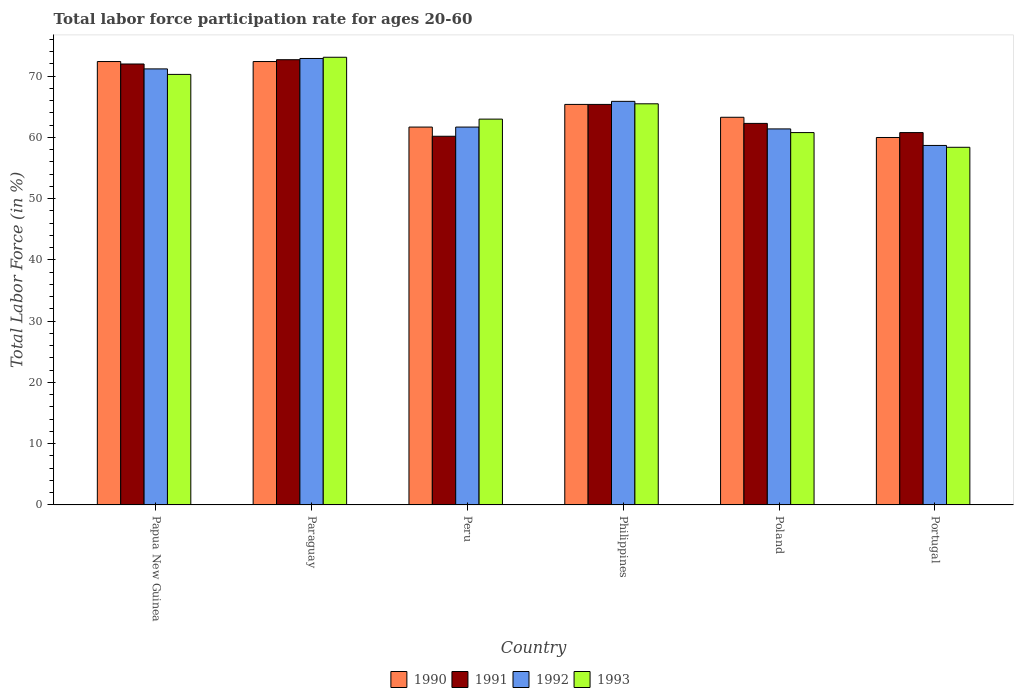How many groups of bars are there?
Offer a terse response. 6. Are the number of bars on each tick of the X-axis equal?
Provide a short and direct response. Yes. How many bars are there on the 3rd tick from the left?
Ensure brevity in your answer.  4. How many bars are there on the 4th tick from the right?
Keep it short and to the point. 4. What is the labor force participation rate in 1991 in Portugal?
Your response must be concise. 60.8. Across all countries, what is the maximum labor force participation rate in 1991?
Ensure brevity in your answer.  72.7. Across all countries, what is the minimum labor force participation rate in 1991?
Your response must be concise. 60.2. In which country was the labor force participation rate in 1991 maximum?
Your answer should be very brief. Paraguay. In which country was the labor force participation rate in 1992 minimum?
Keep it short and to the point. Portugal. What is the total labor force participation rate in 1990 in the graph?
Ensure brevity in your answer.  395.2. What is the difference between the labor force participation rate in 1991 in Paraguay and that in Peru?
Offer a terse response. 12.5. What is the difference between the labor force participation rate in 1991 in Poland and the labor force participation rate in 1993 in Paraguay?
Your response must be concise. -10.8. What is the average labor force participation rate in 1991 per country?
Your answer should be compact. 65.57. What is the difference between the labor force participation rate of/in 1992 and labor force participation rate of/in 1993 in Paraguay?
Your response must be concise. -0.2. In how many countries, is the labor force participation rate in 1990 greater than 26 %?
Ensure brevity in your answer.  6. What is the ratio of the labor force participation rate in 1990 in Papua New Guinea to that in Philippines?
Provide a short and direct response. 1.11. What is the difference between the highest and the second highest labor force participation rate in 1992?
Your response must be concise. 7. What is the difference between the highest and the lowest labor force participation rate in 1992?
Your answer should be compact. 14.2. Is the sum of the labor force participation rate in 1992 in Paraguay and Philippines greater than the maximum labor force participation rate in 1991 across all countries?
Give a very brief answer. Yes. What does the 4th bar from the right in Paraguay represents?
Your answer should be very brief. 1990. Is it the case that in every country, the sum of the labor force participation rate in 1991 and labor force participation rate in 1992 is greater than the labor force participation rate in 1993?
Make the answer very short. Yes. Are the values on the major ticks of Y-axis written in scientific E-notation?
Make the answer very short. No. Does the graph contain any zero values?
Offer a very short reply. No. Where does the legend appear in the graph?
Make the answer very short. Bottom center. How many legend labels are there?
Your answer should be very brief. 4. What is the title of the graph?
Your answer should be compact. Total labor force participation rate for ages 20-60. Does "1993" appear as one of the legend labels in the graph?
Provide a succinct answer. Yes. What is the label or title of the X-axis?
Make the answer very short. Country. What is the label or title of the Y-axis?
Keep it short and to the point. Total Labor Force (in %). What is the Total Labor Force (in %) in 1990 in Papua New Guinea?
Give a very brief answer. 72.4. What is the Total Labor Force (in %) of 1991 in Papua New Guinea?
Your answer should be compact. 72. What is the Total Labor Force (in %) of 1992 in Papua New Guinea?
Give a very brief answer. 71.2. What is the Total Labor Force (in %) of 1993 in Papua New Guinea?
Provide a short and direct response. 70.3. What is the Total Labor Force (in %) in 1990 in Paraguay?
Ensure brevity in your answer.  72.4. What is the Total Labor Force (in %) in 1991 in Paraguay?
Offer a terse response. 72.7. What is the Total Labor Force (in %) of 1992 in Paraguay?
Your answer should be very brief. 72.9. What is the Total Labor Force (in %) of 1993 in Paraguay?
Your response must be concise. 73.1. What is the Total Labor Force (in %) in 1990 in Peru?
Give a very brief answer. 61.7. What is the Total Labor Force (in %) of 1991 in Peru?
Provide a succinct answer. 60.2. What is the Total Labor Force (in %) in 1992 in Peru?
Your response must be concise. 61.7. What is the Total Labor Force (in %) of 1990 in Philippines?
Your response must be concise. 65.4. What is the Total Labor Force (in %) of 1991 in Philippines?
Provide a succinct answer. 65.4. What is the Total Labor Force (in %) in 1992 in Philippines?
Your answer should be very brief. 65.9. What is the Total Labor Force (in %) of 1993 in Philippines?
Your answer should be very brief. 65.5. What is the Total Labor Force (in %) of 1990 in Poland?
Give a very brief answer. 63.3. What is the Total Labor Force (in %) in 1991 in Poland?
Keep it short and to the point. 62.3. What is the Total Labor Force (in %) of 1992 in Poland?
Provide a succinct answer. 61.4. What is the Total Labor Force (in %) of 1993 in Poland?
Offer a very short reply. 60.8. What is the Total Labor Force (in %) in 1991 in Portugal?
Provide a succinct answer. 60.8. What is the Total Labor Force (in %) of 1992 in Portugal?
Your response must be concise. 58.7. What is the Total Labor Force (in %) of 1993 in Portugal?
Ensure brevity in your answer.  58.4. Across all countries, what is the maximum Total Labor Force (in %) of 1990?
Give a very brief answer. 72.4. Across all countries, what is the maximum Total Labor Force (in %) in 1991?
Offer a very short reply. 72.7. Across all countries, what is the maximum Total Labor Force (in %) of 1992?
Your answer should be very brief. 72.9. Across all countries, what is the maximum Total Labor Force (in %) in 1993?
Provide a short and direct response. 73.1. Across all countries, what is the minimum Total Labor Force (in %) of 1991?
Your response must be concise. 60.2. Across all countries, what is the minimum Total Labor Force (in %) in 1992?
Keep it short and to the point. 58.7. Across all countries, what is the minimum Total Labor Force (in %) in 1993?
Your response must be concise. 58.4. What is the total Total Labor Force (in %) of 1990 in the graph?
Ensure brevity in your answer.  395.2. What is the total Total Labor Force (in %) in 1991 in the graph?
Your answer should be compact. 393.4. What is the total Total Labor Force (in %) of 1992 in the graph?
Your answer should be compact. 391.8. What is the total Total Labor Force (in %) in 1993 in the graph?
Your answer should be compact. 391.1. What is the difference between the Total Labor Force (in %) in 1990 in Papua New Guinea and that in Paraguay?
Your response must be concise. 0. What is the difference between the Total Labor Force (in %) of 1992 in Papua New Guinea and that in Paraguay?
Offer a very short reply. -1.7. What is the difference between the Total Labor Force (in %) in 1993 in Papua New Guinea and that in Paraguay?
Your answer should be very brief. -2.8. What is the difference between the Total Labor Force (in %) in 1990 in Papua New Guinea and that in Peru?
Your response must be concise. 10.7. What is the difference between the Total Labor Force (in %) of 1992 in Papua New Guinea and that in Peru?
Offer a terse response. 9.5. What is the difference between the Total Labor Force (in %) of 1993 in Papua New Guinea and that in Peru?
Give a very brief answer. 7.3. What is the difference between the Total Labor Force (in %) in 1990 in Papua New Guinea and that in Philippines?
Keep it short and to the point. 7. What is the difference between the Total Labor Force (in %) in 1991 in Papua New Guinea and that in Philippines?
Your answer should be compact. 6.6. What is the difference between the Total Labor Force (in %) in 1993 in Papua New Guinea and that in Philippines?
Make the answer very short. 4.8. What is the difference between the Total Labor Force (in %) in 1990 in Papua New Guinea and that in Poland?
Keep it short and to the point. 9.1. What is the difference between the Total Labor Force (in %) in 1991 in Papua New Guinea and that in Poland?
Offer a very short reply. 9.7. What is the difference between the Total Labor Force (in %) of 1992 in Papua New Guinea and that in Poland?
Your answer should be compact. 9.8. What is the difference between the Total Labor Force (in %) of 1993 in Papua New Guinea and that in Poland?
Give a very brief answer. 9.5. What is the difference between the Total Labor Force (in %) in 1990 in Papua New Guinea and that in Portugal?
Your response must be concise. 12.4. What is the difference between the Total Labor Force (in %) of 1991 in Papua New Guinea and that in Portugal?
Your response must be concise. 11.2. What is the difference between the Total Labor Force (in %) in 1990 in Paraguay and that in Peru?
Your response must be concise. 10.7. What is the difference between the Total Labor Force (in %) in 1991 in Paraguay and that in Peru?
Give a very brief answer. 12.5. What is the difference between the Total Labor Force (in %) in 1993 in Paraguay and that in Philippines?
Give a very brief answer. 7.6. What is the difference between the Total Labor Force (in %) in 1990 in Paraguay and that in Poland?
Provide a succinct answer. 9.1. What is the difference between the Total Labor Force (in %) in 1992 in Paraguay and that in Poland?
Make the answer very short. 11.5. What is the difference between the Total Labor Force (in %) in 1993 in Paraguay and that in Poland?
Keep it short and to the point. 12.3. What is the difference between the Total Labor Force (in %) of 1990 in Paraguay and that in Portugal?
Offer a very short reply. 12.4. What is the difference between the Total Labor Force (in %) of 1991 in Paraguay and that in Portugal?
Ensure brevity in your answer.  11.9. What is the difference between the Total Labor Force (in %) of 1993 in Paraguay and that in Portugal?
Your answer should be compact. 14.7. What is the difference between the Total Labor Force (in %) in 1991 in Peru and that in Philippines?
Provide a short and direct response. -5.2. What is the difference between the Total Labor Force (in %) of 1992 in Peru and that in Philippines?
Ensure brevity in your answer.  -4.2. What is the difference between the Total Labor Force (in %) in 1992 in Peru and that in Poland?
Ensure brevity in your answer.  0.3. What is the difference between the Total Labor Force (in %) in 1993 in Peru and that in Poland?
Your answer should be very brief. 2.2. What is the difference between the Total Labor Force (in %) in 1991 in Peru and that in Portugal?
Make the answer very short. -0.6. What is the difference between the Total Labor Force (in %) in 1990 in Philippines and that in Poland?
Make the answer very short. 2.1. What is the difference between the Total Labor Force (in %) in 1993 in Philippines and that in Poland?
Your answer should be compact. 4.7. What is the difference between the Total Labor Force (in %) of 1990 in Philippines and that in Portugal?
Your answer should be very brief. 5.4. What is the difference between the Total Labor Force (in %) of 1990 in Poland and that in Portugal?
Make the answer very short. 3.3. What is the difference between the Total Labor Force (in %) in 1991 in Poland and that in Portugal?
Your answer should be very brief. 1.5. What is the difference between the Total Labor Force (in %) in 1993 in Poland and that in Portugal?
Make the answer very short. 2.4. What is the difference between the Total Labor Force (in %) in 1990 in Papua New Guinea and the Total Labor Force (in %) in 1991 in Paraguay?
Ensure brevity in your answer.  -0.3. What is the difference between the Total Labor Force (in %) in 1990 in Papua New Guinea and the Total Labor Force (in %) in 1993 in Paraguay?
Provide a succinct answer. -0.7. What is the difference between the Total Labor Force (in %) in 1991 in Papua New Guinea and the Total Labor Force (in %) in 1993 in Paraguay?
Your response must be concise. -1.1. What is the difference between the Total Labor Force (in %) of 1992 in Papua New Guinea and the Total Labor Force (in %) of 1993 in Paraguay?
Give a very brief answer. -1.9. What is the difference between the Total Labor Force (in %) of 1990 in Papua New Guinea and the Total Labor Force (in %) of 1992 in Peru?
Your answer should be very brief. 10.7. What is the difference between the Total Labor Force (in %) of 1990 in Papua New Guinea and the Total Labor Force (in %) of 1993 in Peru?
Provide a succinct answer. 9.4. What is the difference between the Total Labor Force (in %) in 1991 in Papua New Guinea and the Total Labor Force (in %) in 1992 in Peru?
Your response must be concise. 10.3. What is the difference between the Total Labor Force (in %) of 1992 in Papua New Guinea and the Total Labor Force (in %) of 1993 in Peru?
Your response must be concise. 8.2. What is the difference between the Total Labor Force (in %) of 1990 in Papua New Guinea and the Total Labor Force (in %) of 1991 in Philippines?
Your answer should be compact. 7. What is the difference between the Total Labor Force (in %) in 1990 in Papua New Guinea and the Total Labor Force (in %) in 1993 in Philippines?
Your answer should be compact. 6.9. What is the difference between the Total Labor Force (in %) of 1991 in Papua New Guinea and the Total Labor Force (in %) of 1992 in Philippines?
Provide a succinct answer. 6.1. What is the difference between the Total Labor Force (in %) in 1991 in Papua New Guinea and the Total Labor Force (in %) in 1993 in Philippines?
Make the answer very short. 6.5. What is the difference between the Total Labor Force (in %) of 1992 in Papua New Guinea and the Total Labor Force (in %) of 1993 in Philippines?
Keep it short and to the point. 5.7. What is the difference between the Total Labor Force (in %) of 1990 in Papua New Guinea and the Total Labor Force (in %) of 1991 in Poland?
Give a very brief answer. 10.1. What is the difference between the Total Labor Force (in %) of 1990 in Papua New Guinea and the Total Labor Force (in %) of 1992 in Poland?
Your answer should be very brief. 11. What is the difference between the Total Labor Force (in %) in 1991 in Papua New Guinea and the Total Labor Force (in %) in 1992 in Poland?
Your response must be concise. 10.6. What is the difference between the Total Labor Force (in %) in 1992 in Papua New Guinea and the Total Labor Force (in %) in 1993 in Poland?
Give a very brief answer. 10.4. What is the difference between the Total Labor Force (in %) of 1990 in Papua New Guinea and the Total Labor Force (in %) of 1991 in Portugal?
Your answer should be compact. 11.6. What is the difference between the Total Labor Force (in %) in 1990 in Papua New Guinea and the Total Labor Force (in %) in 1992 in Portugal?
Make the answer very short. 13.7. What is the difference between the Total Labor Force (in %) of 1991 in Papua New Guinea and the Total Labor Force (in %) of 1992 in Portugal?
Give a very brief answer. 13.3. What is the difference between the Total Labor Force (in %) of 1992 in Papua New Guinea and the Total Labor Force (in %) of 1993 in Portugal?
Provide a succinct answer. 12.8. What is the difference between the Total Labor Force (in %) of 1990 in Paraguay and the Total Labor Force (in %) of 1992 in Peru?
Provide a short and direct response. 10.7. What is the difference between the Total Labor Force (in %) in 1991 in Paraguay and the Total Labor Force (in %) in 1993 in Peru?
Offer a very short reply. 9.7. What is the difference between the Total Labor Force (in %) in 1991 in Paraguay and the Total Labor Force (in %) in 1992 in Philippines?
Your response must be concise. 6.8. What is the difference between the Total Labor Force (in %) in 1992 in Paraguay and the Total Labor Force (in %) in 1993 in Philippines?
Offer a terse response. 7.4. What is the difference between the Total Labor Force (in %) of 1990 in Paraguay and the Total Labor Force (in %) of 1991 in Poland?
Give a very brief answer. 10.1. What is the difference between the Total Labor Force (in %) in 1990 in Paraguay and the Total Labor Force (in %) in 1993 in Poland?
Your answer should be compact. 11.6. What is the difference between the Total Labor Force (in %) in 1990 in Paraguay and the Total Labor Force (in %) in 1991 in Portugal?
Your answer should be very brief. 11.6. What is the difference between the Total Labor Force (in %) in 1990 in Paraguay and the Total Labor Force (in %) in 1993 in Portugal?
Offer a very short reply. 14. What is the difference between the Total Labor Force (in %) of 1990 in Peru and the Total Labor Force (in %) of 1991 in Philippines?
Your response must be concise. -3.7. What is the difference between the Total Labor Force (in %) in 1990 in Peru and the Total Labor Force (in %) in 1992 in Philippines?
Ensure brevity in your answer.  -4.2. What is the difference between the Total Labor Force (in %) in 1990 in Peru and the Total Labor Force (in %) in 1993 in Philippines?
Ensure brevity in your answer.  -3.8. What is the difference between the Total Labor Force (in %) of 1991 in Peru and the Total Labor Force (in %) of 1993 in Philippines?
Your answer should be very brief. -5.3. What is the difference between the Total Labor Force (in %) in 1990 in Peru and the Total Labor Force (in %) in 1992 in Poland?
Give a very brief answer. 0.3. What is the difference between the Total Labor Force (in %) in 1992 in Peru and the Total Labor Force (in %) in 1993 in Poland?
Your answer should be compact. 0.9. What is the difference between the Total Labor Force (in %) of 1990 in Peru and the Total Labor Force (in %) of 1993 in Portugal?
Provide a succinct answer. 3.3. What is the difference between the Total Labor Force (in %) of 1991 in Peru and the Total Labor Force (in %) of 1992 in Portugal?
Make the answer very short. 1.5. What is the difference between the Total Labor Force (in %) of 1991 in Peru and the Total Labor Force (in %) of 1993 in Portugal?
Offer a terse response. 1.8. What is the difference between the Total Labor Force (in %) in 1992 in Peru and the Total Labor Force (in %) in 1993 in Portugal?
Your response must be concise. 3.3. What is the difference between the Total Labor Force (in %) of 1990 in Philippines and the Total Labor Force (in %) of 1992 in Poland?
Your answer should be compact. 4. What is the difference between the Total Labor Force (in %) in 1991 in Philippines and the Total Labor Force (in %) in 1992 in Poland?
Provide a succinct answer. 4. What is the difference between the Total Labor Force (in %) of 1992 in Philippines and the Total Labor Force (in %) of 1993 in Poland?
Provide a short and direct response. 5.1. What is the difference between the Total Labor Force (in %) in 1990 in Philippines and the Total Labor Force (in %) in 1991 in Portugal?
Your response must be concise. 4.6. What is the difference between the Total Labor Force (in %) of 1991 in Philippines and the Total Labor Force (in %) of 1992 in Portugal?
Keep it short and to the point. 6.7. What is the difference between the Total Labor Force (in %) in 1992 in Philippines and the Total Labor Force (in %) in 1993 in Portugal?
Offer a terse response. 7.5. What is the difference between the Total Labor Force (in %) in 1990 in Poland and the Total Labor Force (in %) in 1991 in Portugal?
Make the answer very short. 2.5. What is the difference between the Total Labor Force (in %) in 1991 in Poland and the Total Labor Force (in %) in 1993 in Portugal?
Provide a short and direct response. 3.9. What is the difference between the Total Labor Force (in %) in 1992 in Poland and the Total Labor Force (in %) in 1993 in Portugal?
Make the answer very short. 3. What is the average Total Labor Force (in %) of 1990 per country?
Make the answer very short. 65.87. What is the average Total Labor Force (in %) in 1991 per country?
Provide a succinct answer. 65.57. What is the average Total Labor Force (in %) of 1992 per country?
Provide a short and direct response. 65.3. What is the average Total Labor Force (in %) in 1993 per country?
Provide a short and direct response. 65.18. What is the difference between the Total Labor Force (in %) of 1990 and Total Labor Force (in %) of 1992 in Papua New Guinea?
Provide a succinct answer. 1.2. What is the difference between the Total Labor Force (in %) in 1990 and Total Labor Force (in %) in 1993 in Papua New Guinea?
Your answer should be compact. 2.1. What is the difference between the Total Labor Force (in %) of 1991 and Total Labor Force (in %) of 1992 in Papua New Guinea?
Ensure brevity in your answer.  0.8. What is the difference between the Total Labor Force (in %) in 1991 and Total Labor Force (in %) in 1993 in Papua New Guinea?
Your answer should be compact. 1.7. What is the difference between the Total Labor Force (in %) of 1992 and Total Labor Force (in %) of 1993 in Papua New Guinea?
Your response must be concise. 0.9. What is the difference between the Total Labor Force (in %) in 1990 and Total Labor Force (in %) in 1991 in Paraguay?
Keep it short and to the point. -0.3. What is the difference between the Total Labor Force (in %) of 1990 and Total Labor Force (in %) of 1992 in Paraguay?
Give a very brief answer. -0.5. What is the difference between the Total Labor Force (in %) in 1990 and Total Labor Force (in %) in 1993 in Paraguay?
Offer a very short reply. -0.7. What is the difference between the Total Labor Force (in %) of 1990 and Total Labor Force (in %) of 1992 in Peru?
Ensure brevity in your answer.  0. What is the difference between the Total Labor Force (in %) of 1991 and Total Labor Force (in %) of 1992 in Peru?
Your answer should be compact. -1.5. What is the difference between the Total Labor Force (in %) in 1992 and Total Labor Force (in %) in 1993 in Peru?
Offer a very short reply. -1.3. What is the difference between the Total Labor Force (in %) of 1990 and Total Labor Force (in %) of 1991 in Philippines?
Your answer should be very brief. 0. What is the difference between the Total Labor Force (in %) in 1990 and Total Labor Force (in %) in 1992 in Philippines?
Keep it short and to the point. -0.5. What is the difference between the Total Labor Force (in %) of 1990 and Total Labor Force (in %) of 1993 in Philippines?
Offer a very short reply. -0.1. What is the difference between the Total Labor Force (in %) of 1991 and Total Labor Force (in %) of 1992 in Philippines?
Provide a short and direct response. -0.5. What is the difference between the Total Labor Force (in %) of 1990 and Total Labor Force (in %) of 1991 in Poland?
Provide a short and direct response. 1. What is the difference between the Total Labor Force (in %) of 1990 and Total Labor Force (in %) of 1993 in Poland?
Provide a short and direct response. 2.5. What is the difference between the Total Labor Force (in %) of 1991 and Total Labor Force (in %) of 1993 in Poland?
Provide a succinct answer. 1.5. What is the difference between the Total Labor Force (in %) in 1992 and Total Labor Force (in %) in 1993 in Poland?
Ensure brevity in your answer.  0.6. What is the difference between the Total Labor Force (in %) in 1992 and Total Labor Force (in %) in 1993 in Portugal?
Your response must be concise. 0.3. What is the ratio of the Total Labor Force (in %) in 1991 in Papua New Guinea to that in Paraguay?
Keep it short and to the point. 0.99. What is the ratio of the Total Labor Force (in %) in 1992 in Papua New Guinea to that in Paraguay?
Ensure brevity in your answer.  0.98. What is the ratio of the Total Labor Force (in %) in 1993 in Papua New Guinea to that in Paraguay?
Offer a terse response. 0.96. What is the ratio of the Total Labor Force (in %) in 1990 in Papua New Guinea to that in Peru?
Your response must be concise. 1.17. What is the ratio of the Total Labor Force (in %) of 1991 in Papua New Guinea to that in Peru?
Offer a terse response. 1.2. What is the ratio of the Total Labor Force (in %) in 1992 in Papua New Guinea to that in Peru?
Offer a very short reply. 1.15. What is the ratio of the Total Labor Force (in %) in 1993 in Papua New Guinea to that in Peru?
Provide a short and direct response. 1.12. What is the ratio of the Total Labor Force (in %) in 1990 in Papua New Guinea to that in Philippines?
Keep it short and to the point. 1.11. What is the ratio of the Total Labor Force (in %) of 1991 in Papua New Guinea to that in Philippines?
Ensure brevity in your answer.  1.1. What is the ratio of the Total Labor Force (in %) in 1992 in Papua New Guinea to that in Philippines?
Your answer should be very brief. 1.08. What is the ratio of the Total Labor Force (in %) in 1993 in Papua New Guinea to that in Philippines?
Your answer should be compact. 1.07. What is the ratio of the Total Labor Force (in %) of 1990 in Papua New Guinea to that in Poland?
Your response must be concise. 1.14. What is the ratio of the Total Labor Force (in %) in 1991 in Papua New Guinea to that in Poland?
Offer a very short reply. 1.16. What is the ratio of the Total Labor Force (in %) in 1992 in Papua New Guinea to that in Poland?
Keep it short and to the point. 1.16. What is the ratio of the Total Labor Force (in %) in 1993 in Papua New Guinea to that in Poland?
Keep it short and to the point. 1.16. What is the ratio of the Total Labor Force (in %) of 1990 in Papua New Guinea to that in Portugal?
Provide a succinct answer. 1.21. What is the ratio of the Total Labor Force (in %) of 1991 in Papua New Guinea to that in Portugal?
Your answer should be very brief. 1.18. What is the ratio of the Total Labor Force (in %) in 1992 in Papua New Guinea to that in Portugal?
Your answer should be very brief. 1.21. What is the ratio of the Total Labor Force (in %) of 1993 in Papua New Guinea to that in Portugal?
Provide a succinct answer. 1.2. What is the ratio of the Total Labor Force (in %) in 1990 in Paraguay to that in Peru?
Provide a succinct answer. 1.17. What is the ratio of the Total Labor Force (in %) in 1991 in Paraguay to that in Peru?
Offer a terse response. 1.21. What is the ratio of the Total Labor Force (in %) of 1992 in Paraguay to that in Peru?
Keep it short and to the point. 1.18. What is the ratio of the Total Labor Force (in %) in 1993 in Paraguay to that in Peru?
Make the answer very short. 1.16. What is the ratio of the Total Labor Force (in %) of 1990 in Paraguay to that in Philippines?
Give a very brief answer. 1.11. What is the ratio of the Total Labor Force (in %) of 1991 in Paraguay to that in Philippines?
Your response must be concise. 1.11. What is the ratio of the Total Labor Force (in %) of 1992 in Paraguay to that in Philippines?
Provide a short and direct response. 1.11. What is the ratio of the Total Labor Force (in %) of 1993 in Paraguay to that in Philippines?
Your answer should be very brief. 1.12. What is the ratio of the Total Labor Force (in %) of 1990 in Paraguay to that in Poland?
Ensure brevity in your answer.  1.14. What is the ratio of the Total Labor Force (in %) of 1991 in Paraguay to that in Poland?
Make the answer very short. 1.17. What is the ratio of the Total Labor Force (in %) in 1992 in Paraguay to that in Poland?
Your response must be concise. 1.19. What is the ratio of the Total Labor Force (in %) in 1993 in Paraguay to that in Poland?
Make the answer very short. 1.2. What is the ratio of the Total Labor Force (in %) of 1990 in Paraguay to that in Portugal?
Your answer should be compact. 1.21. What is the ratio of the Total Labor Force (in %) of 1991 in Paraguay to that in Portugal?
Offer a very short reply. 1.2. What is the ratio of the Total Labor Force (in %) in 1992 in Paraguay to that in Portugal?
Provide a succinct answer. 1.24. What is the ratio of the Total Labor Force (in %) of 1993 in Paraguay to that in Portugal?
Give a very brief answer. 1.25. What is the ratio of the Total Labor Force (in %) in 1990 in Peru to that in Philippines?
Give a very brief answer. 0.94. What is the ratio of the Total Labor Force (in %) of 1991 in Peru to that in Philippines?
Make the answer very short. 0.92. What is the ratio of the Total Labor Force (in %) of 1992 in Peru to that in Philippines?
Provide a succinct answer. 0.94. What is the ratio of the Total Labor Force (in %) in 1993 in Peru to that in Philippines?
Make the answer very short. 0.96. What is the ratio of the Total Labor Force (in %) in 1990 in Peru to that in Poland?
Your answer should be very brief. 0.97. What is the ratio of the Total Labor Force (in %) of 1991 in Peru to that in Poland?
Provide a short and direct response. 0.97. What is the ratio of the Total Labor Force (in %) of 1993 in Peru to that in Poland?
Provide a succinct answer. 1.04. What is the ratio of the Total Labor Force (in %) of 1990 in Peru to that in Portugal?
Offer a terse response. 1.03. What is the ratio of the Total Labor Force (in %) of 1992 in Peru to that in Portugal?
Keep it short and to the point. 1.05. What is the ratio of the Total Labor Force (in %) in 1993 in Peru to that in Portugal?
Your answer should be very brief. 1.08. What is the ratio of the Total Labor Force (in %) in 1990 in Philippines to that in Poland?
Your answer should be very brief. 1.03. What is the ratio of the Total Labor Force (in %) in 1991 in Philippines to that in Poland?
Your answer should be compact. 1.05. What is the ratio of the Total Labor Force (in %) in 1992 in Philippines to that in Poland?
Your answer should be very brief. 1.07. What is the ratio of the Total Labor Force (in %) of 1993 in Philippines to that in Poland?
Give a very brief answer. 1.08. What is the ratio of the Total Labor Force (in %) in 1990 in Philippines to that in Portugal?
Provide a succinct answer. 1.09. What is the ratio of the Total Labor Force (in %) of 1991 in Philippines to that in Portugal?
Your answer should be very brief. 1.08. What is the ratio of the Total Labor Force (in %) in 1992 in Philippines to that in Portugal?
Provide a succinct answer. 1.12. What is the ratio of the Total Labor Force (in %) of 1993 in Philippines to that in Portugal?
Your response must be concise. 1.12. What is the ratio of the Total Labor Force (in %) of 1990 in Poland to that in Portugal?
Ensure brevity in your answer.  1.05. What is the ratio of the Total Labor Force (in %) of 1991 in Poland to that in Portugal?
Your answer should be very brief. 1.02. What is the ratio of the Total Labor Force (in %) of 1992 in Poland to that in Portugal?
Give a very brief answer. 1.05. What is the ratio of the Total Labor Force (in %) in 1993 in Poland to that in Portugal?
Offer a very short reply. 1.04. What is the difference between the highest and the second highest Total Labor Force (in %) of 1991?
Keep it short and to the point. 0.7. What is the difference between the highest and the second highest Total Labor Force (in %) of 1993?
Give a very brief answer. 2.8. What is the difference between the highest and the lowest Total Labor Force (in %) of 1990?
Provide a succinct answer. 12.4. What is the difference between the highest and the lowest Total Labor Force (in %) in 1991?
Give a very brief answer. 12.5. What is the difference between the highest and the lowest Total Labor Force (in %) in 1993?
Offer a terse response. 14.7. 